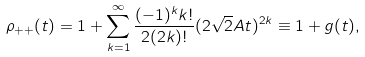Convert formula to latex. <formula><loc_0><loc_0><loc_500><loc_500>\rho _ { + + } ( t ) = 1 + \sum _ { k = 1 } ^ { \infty } \frac { ( - 1 ) ^ { k } k ! } { 2 ( 2 k ) ! } ( 2 \sqrt { 2 } A t ) ^ { 2 k } \equiv 1 + g ( t ) ,</formula> 